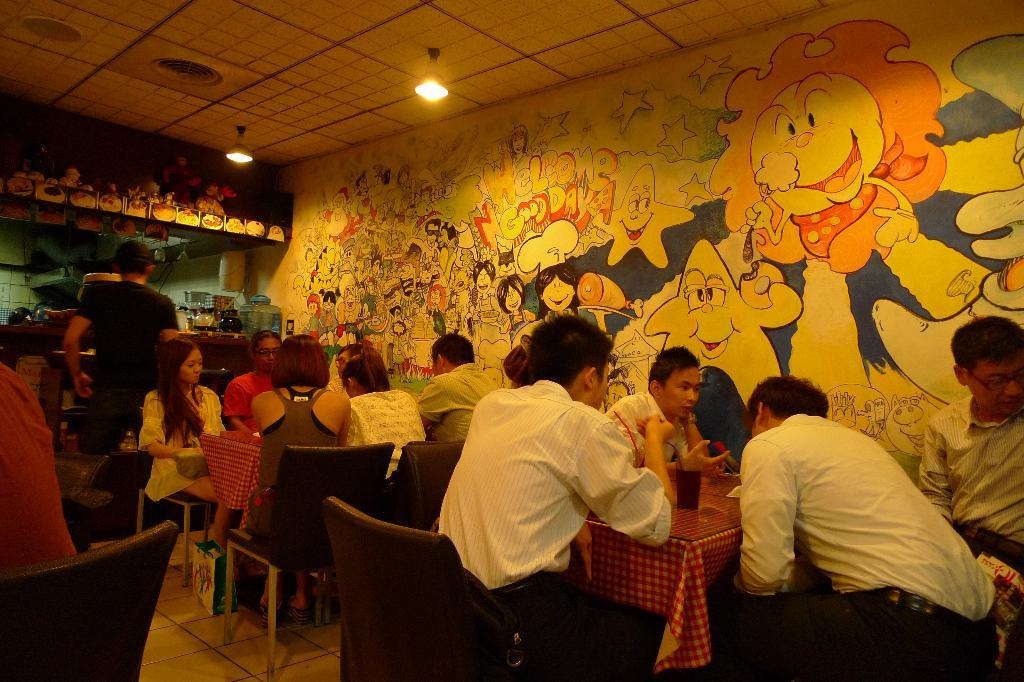How many people are sitting on chairs in the image? There are multiple people sitting on chairs in the image. What is the person near the kitchen doing? The person standing near the kitchen is not specified in the facts, so we cannot determine their actions. Can you see the seashore in the image? No, the seashore is not present in the image. What property is being pushed by the person standing near the kitchen? There is no person pushing any property in the image, as their actions are not specified in the facts. 